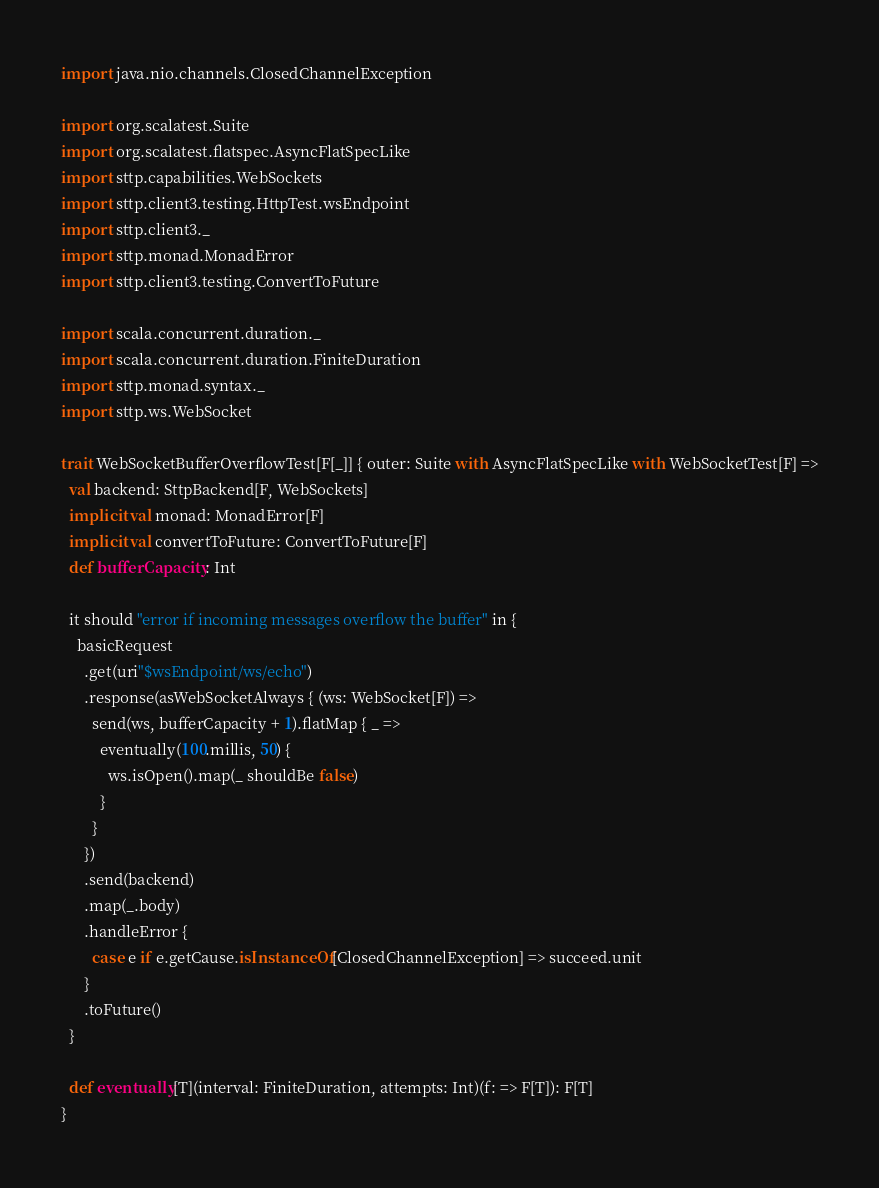<code> <loc_0><loc_0><loc_500><loc_500><_Scala_>
import java.nio.channels.ClosedChannelException

import org.scalatest.Suite
import org.scalatest.flatspec.AsyncFlatSpecLike
import sttp.capabilities.WebSockets
import sttp.client3.testing.HttpTest.wsEndpoint
import sttp.client3._
import sttp.monad.MonadError
import sttp.client3.testing.ConvertToFuture

import scala.concurrent.duration._
import scala.concurrent.duration.FiniteDuration
import sttp.monad.syntax._
import sttp.ws.WebSocket

trait WebSocketBufferOverflowTest[F[_]] { outer: Suite with AsyncFlatSpecLike with WebSocketTest[F] =>
  val backend: SttpBackend[F, WebSockets]
  implicit val monad: MonadError[F]
  implicit val convertToFuture: ConvertToFuture[F]
  def bufferCapacity: Int

  it should "error if incoming messages overflow the buffer" in {
    basicRequest
      .get(uri"$wsEndpoint/ws/echo")
      .response(asWebSocketAlways { (ws: WebSocket[F]) =>
        send(ws, bufferCapacity + 1).flatMap { _ =>
          eventually(100.millis, 50) {
            ws.isOpen().map(_ shouldBe false)
          }
        }
      })
      .send(backend)
      .map(_.body)
      .handleError {
        case e if e.getCause.isInstanceOf[ClosedChannelException] => succeed.unit
      }
      .toFuture()
  }

  def eventually[T](interval: FiniteDuration, attempts: Int)(f: => F[T]): F[T]
}
</code> 